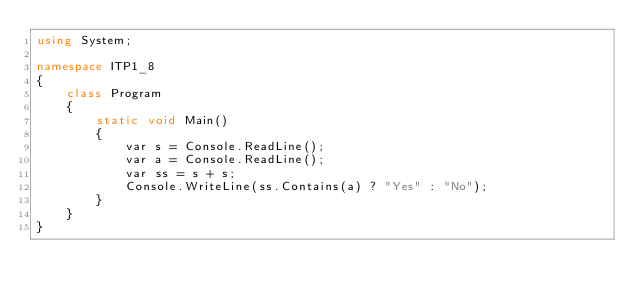Convert code to text. <code><loc_0><loc_0><loc_500><loc_500><_C#_>using System;

namespace ITP1_8
{
    class Program
    {
        static void Main()
        {
            var s = Console.ReadLine();
            var a = Console.ReadLine();
            var ss = s + s;
            Console.WriteLine(ss.Contains(a) ? "Yes" : "No");
        }
    }
}</code> 